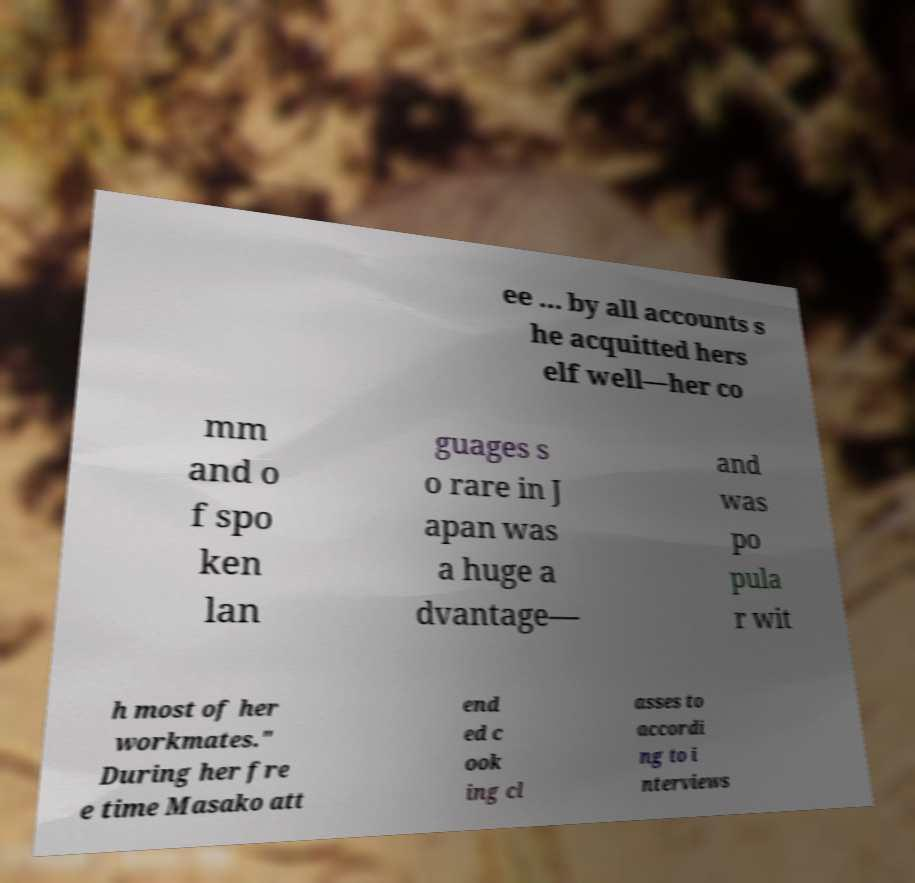For documentation purposes, I need the text within this image transcribed. Could you provide that? ee ... by all accounts s he acquitted hers elf well—her co mm and o f spo ken lan guages s o rare in J apan was a huge a dvantage— and was po pula r wit h most of her workmates." During her fre e time Masako att end ed c ook ing cl asses to accordi ng to i nterviews 